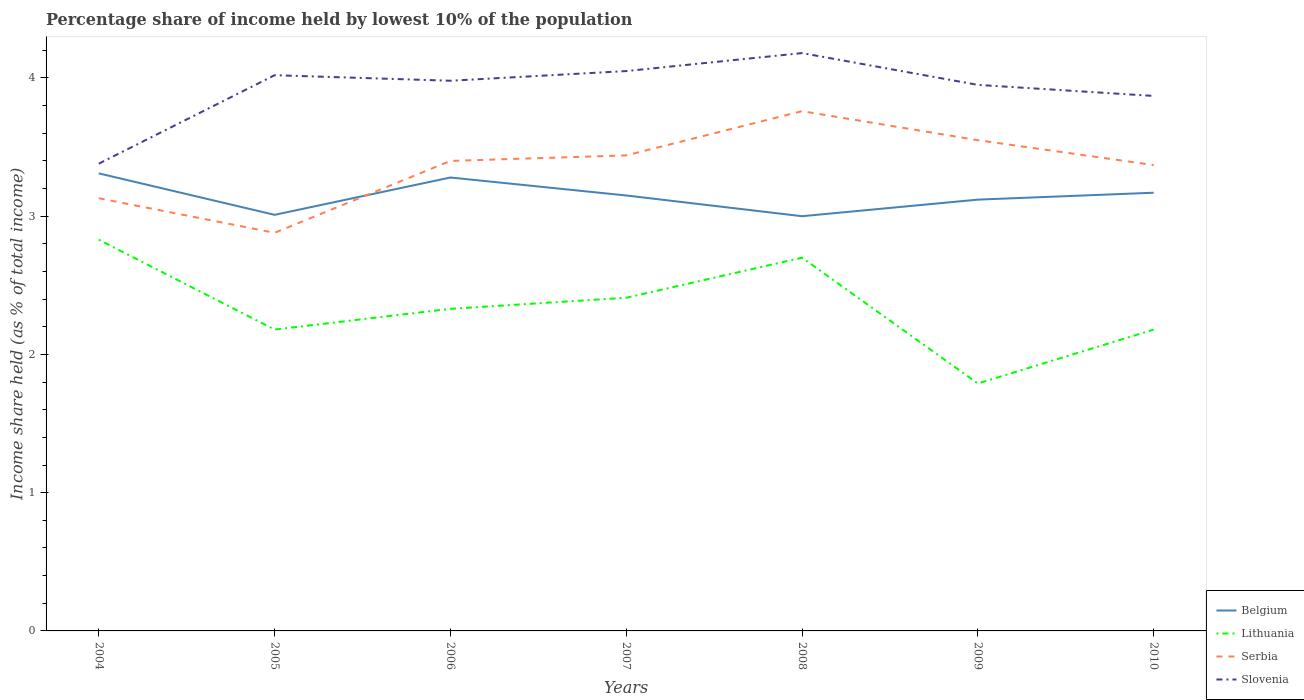Is the number of lines equal to the number of legend labels?
Provide a succinct answer. Yes. Across all years, what is the maximum percentage share of income held by lowest 10% of the population in Slovenia?
Keep it short and to the point. 3.38. What is the total percentage share of income held by lowest 10% of the population in Belgium in the graph?
Your response must be concise. -0.11. What is the difference between the highest and the second highest percentage share of income held by lowest 10% of the population in Slovenia?
Your answer should be compact. 0.8. How many lines are there?
Offer a terse response. 4. How many years are there in the graph?
Provide a short and direct response. 7. What is the difference between two consecutive major ticks on the Y-axis?
Offer a terse response. 1. Are the values on the major ticks of Y-axis written in scientific E-notation?
Make the answer very short. No. Does the graph contain any zero values?
Your response must be concise. No. Does the graph contain grids?
Make the answer very short. No. How many legend labels are there?
Offer a terse response. 4. How are the legend labels stacked?
Your response must be concise. Vertical. What is the title of the graph?
Keep it short and to the point. Percentage share of income held by lowest 10% of the population. Does "Slovenia" appear as one of the legend labels in the graph?
Provide a short and direct response. Yes. What is the label or title of the X-axis?
Offer a very short reply. Years. What is the label or title of the Y-axis?
Offer a very short reply. Income share held (as % of total income). What is the Income share held (as % of total income) in Belgium in 2004?
Make the answer very short. 3.31. What is the Income share held (as % of total income) of Lithuania in 2004?
Offer a very short reply. 2.83. What is the Income share held (as % of total income) in Serbia in 2004?
Provide a short and direct response. 3.13. What is the Income share held (as % of total income) in Slovenia in 2004?
Provide a short and direct response. 3.38. What is the Income share held (as % of total income) of Belgium in 2005?
Provide a succinct answer. 3.01. What is the Income share held (as % of total income) in Lithuania in 2005?
Offer a very short reply. 2.18. What is the Income share held (as % of total income) of Serbia in 2005?
Give a very brief answer. 2.88. What is the Income share held (as % of total income) in Slovenia in 2005?
Your response must be concise. 4.02. What is the Income share held (as % of total income) in Belgium in 2006?
Ensure brevity in your answer.  3.28. What is the Income share held (as % of total income) of Lithuania in 2006?
Your answer should be compact. 2.33. What is the Income share held (as % of total income) in Slovenia in 2006?
Provide a short and direct response. 3.98. What is the Income share held (as % of total income) in Belgium in 2007?
Provide a succinct answer. 3.15. What is the Income share held (as % of total income) of Lithuania in 2007?
Give a very brief answer. 2.41. What is the Income share held (as % of total income) of Serbia in 2007?
Offer a terse response. 3.44. What is the Income share held (as % of total income) of Slovenia in 2007?
Your response must be concise. 4.05. What is the Income share held (as % of total income) in Belgium in 2008?
Keep it short and to the point. 3. What is the Income share held (as % of total income) of Serbia in 2008?
Ensure brevity in your answer.  3.76. What is the Income share held (as % of total income) in Slovenia in 2008?
Provide a succinct answer. 4.18. What is the Income share held (as % of total income) in Belgium in 2009?
Ensure brevity in your answer.  3.12. What is the Income share held (as % of total income) of Lithuania in 2009?
Offer a terse response. 1.79. What is the Income share held (as % of total income) of Serbia in 2009?
Ensure brevity in your answer.  3.55. What is the Income share held (as % of total income) of Slovenia in 2009?
Your answer should be very brief. 3.95. What is the Income share held (as % of total income) in Belgium in 2010?
Your answer should be very brief. 3.17. What is the Income share held (as % of total income) of Lithuania in 2010?
Your answer should be compact. 2.18. What is the Income share held (as % of total income) of Serbia in 2010?
Your answer should be very brief. 3.37. What is the Income share held (as % of total income) in Slovenia in 2010?
Your answer should be compact. 3.87. Across all years, what is the maximum Income share held (as % of total income) in Belgium?
Keep it short and to the point. 3.31. Across all years, what is the maximum Income share held (as % of total income) of Lithuania?
Give a very brief answer. 2.83. Across all years, what is the maximum Income share held (as % of total income) in Serbia?
Your answer should be very brief. 3.76. Across all years, what is the maximum Income share held (as % of total income) of Slovenia?
Provide a short and direct response. 4.18. Across all years, what is the minimum Income share held (as % of total income) in Belgium?
Provide a short and direct response. 3. Across all years, what is the minimum Income share held (as % of total income) in Lithuania?
Provide a succinct answer. 1.79. Across all years, what is the minimum Income share held (as % of total income) in Serbia?
Give a very brief answer. 2.88. Across all years, what is the minimum Income share held (as % of total income) in Slovenia?
Your answer should be compact. 3.38. What is the total Income share held (as % of total income) in Belgium in the graph?
Your answer should be compact. 22.04. What is the total Income share held (as % of total income) of Lithuania in the graph?
Your answer should be very brief. 16.42. What is the total Income share held (as % of total income) of Serbia in the graph?
Provide a succinct answer. 23.53. What is the total Income share held (as % of total income) of Slovenia in the graph?
Your answer should be compact. 27.43. What is the difference between the Income share held (as % of total income) of Belgium in 2004 and that in 2005?
Your answer should be compact. 0.3. What is the difference between the Income share held (as % of total income) in Lithuania in 2004 and that in 2005?
Your response must be concise. 0.65. What is the difference between the Income share held (as % of total income) of Slovenia in 2004 and that in 2005?
Keep it short and to the point. -0.64. What is the difference between the Income share held (as % of total income) of Belgium in 2004 and that in 2006?
Your answer should be very brief. 0.03. What is the difference between the Income share held (as % of total income) of Serbia in 2004 and that in 2006?
Offer a very short reply. -0.27. What is the difference between the Income share held (as % of total income) of Belgium in 2004 and that in 2007?
Offer a very short reply. 0.16. What is the difference between the Income share held (as % of total income) of Lithuania in 2004 and that in 2007?
Your response must be concise. 0.42. What is the difference between the Income share held (as % of total income) in Serbia in 2004 and that in 2007?
Make the answer very short. -0.31. What is the difference between the Income share held (as % of total income) in Slovenia in 2004 and that in 2007?
Offer a very short reply. -0.67. What is the difference between the Income share held (as % of total income) of Belgium in 2004 and that in 2008?
Offer a terse response. 0.31. What is the difference between the Income share held (as % of total income) in Lithuania in 2004 and that in 2008?
Give a very brief answer. 0.13. What is the difference between the Income share held (as % of total income) of Serbia in 2004 and that in 2008?
Make the answer very short. -0.63. What is the difference between the Income share held (as % of total income) in Belgium in 2004 and that in 2009?
Give a very brief answer. 0.19. What is the difference between the Income share held (as % of total income) of Lithuania in 2004 and that in 2009?
Your answer should be compact. 1.04. What is the difference between the Income share held (as % of total income) in Serbia in 2004 and that in 2009?
Your answer should be very brief. -0.42. What is the difference between the Income share held (as % of total income) of Slovenia in 2004 and that in 2009?
Keep it short and to the point. -0.57. What is the difference between the Income share held (as % of total income) in Belgium in 2004 and that in 2010?
Your response must be concise. 0.14. What is the difference between the Income share held (as % of total income) of Lithuania in 2004 and that in 2010?
Keep it short and to the point. 0.65. What is the difference between the Income share held (as % of total income) in Serbia in 2004 and that in 2010?
Your answer should be very brief. -0.24. What is the difference between the Income share held (as % of total income) in Slovenia in 2004 and that in 2010?
Give a very brief answer. -0.49. What is the difference between the Income share held (as % of total income) of Belgium in 2005 and that in 2006?
Keep it short and to the point. -0.27. What is the difference between the Income share held (as % of total income) in Serbia in 2005 and that in 2006?
Offer a terse response. -0.52. What is the difference between the Income share held (as % of total income) of Slovenia in 2005 and that in 2006?
Provide a short and direct response. 0.04. What is the difference between the Income share held (as % of total income) in Belgium in 2005 and that in 2007?
Make the answer very short. -0.14. What is the difference between the Income share held (as % of total income) of Lithuania in 2005 and that in 2007?
Give a very brief answer. -0.23. What is the difference between the Income share held (as % of total income) in Serbia in 2005 and that in 2007?
Your answer should be very brief. -0.56. What is the difference between the Income share held (as % of total income) of Slovenia in 2005 and that in 2007?
Offer a terse response. -0.03. What is the difference between the Income share held (as % of total income) in Belgium in 2005 and that in 2008?
Offer a terse response. 0.01. What is the difference between the Income share held (as % of total income) of Lithuania in 2005 and that in 2008?
Ensure brevity in your answer.  -0.52. What is the difference between the Income share held (as % of total income) of Serbia in 2005 and that in 2008?
Provide a succinct answer. -0.88. What is the difference between the Income share held (as % of total income) of Slovenia in 2005 and that in 2008?
Offer a terse response. -0.16. What is the difference between the Income share held (as % of total income) in Belgium in 2005 and that in 2009?
Keep it short and to the point. -0.11. What is the difference between the Income share held (as % of total income) in Lithuania in 2005 and that in 2009?
Keep it short and to the point. 0.39. What is the difference between the Income share held (as % of total income) in Serbia in 2005 and that in 2009?
Give a very brief answer. -0.67. What is the difference between the Income share held (as % of total income) in Slovenia in 2005 and that in 2009?
Give a very brief answer. 0.07. What is the difference between the Income share held (as % of total income) of Belgium in 2005 and that in 2010?
Your response must be concise. -0.16. What is the difference between the Income share held (as % of total income) in Serbia in 2005 and that in 2010?
Provide a short and direct response. -0.49. What is the difference between the Income share held (as % of total income) in Slovenia in 2005 and that in 2010?
Your answer should be very brief. 0.15. What is the difference between the Income share held (as % of total income) of Belgium in 2006 and that in 2007?
Your response must be concise. 0.13. What is the difference between the Income share held (as % of total income) of Lithuania in 2006 and that in 2007?
Give a very brief answer. -0.08. What is the difference between the Income share held (as % of total income) in Serbia in 2006 and that in 2007?
Your answer should be very brief. -0.04. What is the difference between the Income share held (as % of total income) of Slovenia in 2006 and that in 2007?
Your answer should be compact. -0.07. What is the difference between the Income share held (as % of total income) in Belgium in 2006 and that in 2008?
Offer a very short reply. 0.28. What is the difference between the Income share held (as % of total income) in Lithuania in 2006 and that in 2008?
Your answer should be compact. -0.37. What is the difference between the Income share held (as % of total income) of Serbia in 2006 and that in 2008?
Offer a very short reply. -0.36. What is the difference between the Income share held (as % of total income) of Slovenia in 2006 and that in 2008?
Your answer should be very brief. -0.2. What is the difference between the Income share held (as % of total income) of Belgium in 2006 and that in 2009?
Provide a succinct answer. 0.16. What is the difference between the Income share held (as % of total income) of Lithuania in 2006 and that in 2009?
Offer a very short reply. 0.54. What is the difference between the Income share held (as % of total income) in Serbia in 2006 and that in 2009?
Offer a terse response. -0.15. What is the difference between the Income share held (as % of total income) of Belgium in 2006 and that in 2010?
Your response must be concise. 0.11. What is the difference between the Income share held (as % of total income) of Serbia in 2006 and that in 2010?
Provide a succinct answer. 0.03. What is the difference between the Income share held (as % of total income) of Slovenia in 2006 and that in 2010?
Offer a very short reply. 0.11. What is the difference between the Income share held (as % of total income) of Lithuania in 2007 and that in 2008?
Provide a short and direct response. -0.29. What is the difference between the Income share held (as % of total income) in Serbia in 2007 and that in 2008?
Your answer should be very brief. -0.32. What is the difference between the Income share held (as % of total income) in Slovenia in 2007 and that in 2008?
Offer a very short reply. -0.13. What is the difference between the Income share held (as % of total income) of Lithuania in 2007 and that in 2009?
Your response must be concise. 0.62. What is the difference between the Income share held (as % of total income) of Serbia in 2007 and that in 2009?
Offer a terse response. -0.11. What is the difference between the Income share held (as % of total income) of Slovenia in 2007 and that in 2009?
Make the answer very short. 0.1. What is the difference between the Income share held (as % of total income) in Belgium in 2007 and that in 2010?
Your answer should be compact. -0.02. What is the difference between the Income share held (as % of total income) of Lithuania in 2007 and that in 2010?
Ensure brevity in your answer.  0.23. What is the difference between the Income share held (as % of total income) in Serbia in 2007 and that in 2010?
Your response must be concise. 0.07. What is the difference between the Income share held (as % of total income) in Slovenia in 2007 and that in 2010?
Your answer should be very brief. 0.18. What is the difference between the Income share held (as % of total income) of Belgium in 2008 and that in 2009?
Provide a succinct answer. -0.12. What is the difference between the Income share held (as % of total income) in Lithuania in 2008 and that in 2009?
Your answer should be compact. 0.91. What is the difference between the Income share held (as % of total income) in Serbia in 2008 and that in 2009?
Your answer should be compact. 0.21. What is the difference between the Income share held (as % of total income) of Slovenia in 2008 and that in 2009?
Give a very brief answer. 0.23. What is the difference between the Income share held (as % of total income) in Belgium in 2008 and that in 2010?
Your answer should be compact. -0.17. What is the difference between the Income share held (as % of total income) of Lithuania in 2008 and that in 2010?
Provide a short and direct response. 0.52. What is the difference between the Income share held (as % of total income) in Serbia in 2008 and that in 2010?
Ensure brevity in your answer.  0.39. What is the difference between the Income share held (as % of total income) of Slovenia in 2008 and that in 2010?
Provide a short and direct response. 0.31. What is the difference between the Income share held (as % of total income) of Lithuania in 2009 and that in 2010?
Your answer should be very brief. -0.39. What is the difference between the Income share held (as % of total income) in Serbia in 2009 and that in 2010?
Make the answer very short. 0.18. What is the difference between the Income share held (as % of total income) in Slovenia in 2009 and that in 2010?
Offer a very short reply. 0.08. What is the difference between the Income share held (as % of total income) of Belgium in 2004 and the Income share held (as % of total income) of Lithuania in 2005?
Give a very brief answer. 1.13. What is the difference between the Income share held (as % of total income) of Belgium in 2004 and the Income share held (as % of total income) of Serbia in 2005?
Offer a very short reply. 0.43. What is the difference between the Income share held (as % of total income) of Belgium in 2004 and the Income share held (as % of total income) of Slovenia in 2005?
Your answer should be compact. -0.71. What is the difference between the Income share held (as % of total income) in Lithuania in 2004 and the Income share held (as % of total income) in Slovenia in 2005?
Offer a very short reply. -1.19. What is the difference between the Income share held (as % of total income) of Serbia in 2004 and the Income share held (as % of total income) of Slovenia in 2005?
Provide a succinct answer. -0.89. What is the difference between the Income share held (as % of total income) of Belgium in 2004 and the Income share held (as % of total income) of Lithuania in 2006?
Your response must be concise. 0.98. What is the difference between the Income share held (as % of total income) of Belgium in 2004 and the Income share held (as % of total income) of Serbia in 2006?
Keep it short and to the point. -0.09. What is the difference between the Income share held (as % of total income) in Belgium in 2004 and the Income share held (as % of total income) in Slovenia in 2006?
Your answer should be very brief. -0.67. What is the difference between the Income share held (as % of total income) of Lithuania in 2004 and the Income share held (as % of total income) of Serbia in 2006?
Offer a very short reply. -0.57. What is the difference between the Income share held (as % of total income) of Lithuania in 2004 and the Income share held (as % of total income) of Slovenia in 2006?
Your response must be concise. -1.15. What is the difference between the Income share held (as % of total income) of Serbia in 2004 and the Income share held (as % of total income) of Slovenia in 2006?
Give a very brief answer. -0.85. What is the difference between the Income share held (as % of total income) of Belgium in 2004 and the Income share held (as % of total income) of Serbia in 2007?
Give a very brief answer. -0.13. What is the difference between the Income share held (as % of total income) in Belgium in 2004 and the Income share held (as % of total income) in Slovenia in 2007?
Provide a short and direct response. -0.74. What is the difference between the Income share held (as % of total income) in Lithuania in 2004 and the Income share held (as % of total income) in Serbia in 2007?
Provide a succinct answer. -0.61. What is the difference between the Income share held (as % of total income) in Lithuania in 2004 and the Income share held (as % of total income) in Slovenia in 2007?
Offer a terse response. -1.22. What is the difference between the Income share held (as % of total income) in Serbia in 2004 and the Income share held (as % of total income) in Slovenia in 2007?
Provide a short and direct response. -0.92. What is the difference between the Income share held (as % of total income) of Belgium in 2004 and the Income share held (as % of total income) of Lithuania in 2008?
Keep it short and to the point. 0.61. What is the difference between the Income share held (as % of total income) in Belgium in 2004 and the Income share held (as % of total income) in Serbia in 2008?
Your answer should be compact. -0.45. What is the difference between the Income share held (as % of total income) of Belgium in 2004 and the Income share held (as % of total income) of Slovenia in 2008?
Ensure brevity in your answer.  -0.87. What is the difference between the Income share held (as % of total income) of Lithuania in 2004 and the Income share held (as % of total income) of Serbia in 2008?
Your response must be concise. -0.93. What is the difference between the Income share held (as % of total income) of Lithuania in 2004 and the Income share held (as % of total income) of Slovenia in 2008?
Ensure brevity in your answer.  -1.35. What is the difference between the Income share held (as % of total income) in Serbia in 2004 and the Income share held (as % of total income) in Slovenia in 2008?
Offer a very short reply. -1.05. What is the difference between the Income share held (as % of total income) of Belgium in 2004 and the Income share held (as % of total income) of Lithuania in 2009?
Your answer should be very brief. 1.52. What is the difference between the Income share held (as % of total income) of Belgium in 2004 and the Income share held (as % of total income) of Serbia in 2009?
Ensure brevity in your answer.  -0.24. What is the difference between the Income share held (as % of total income) of Belgium in 2004 and the Income share held (as % of total income) of Slovenia in 2009?
Ensure brevity in your answer.  -0.64. What is the difference between the Income share held (as % of total income) of Lithuania in 2004 and the Income share held (as % of total income) of Serbia in 2009?
Provide a succinct answer. -0.72. What is the difference between the Income share held (as % of total income) in Lithuania in 2004 and the Income share held (as % of total income) in Slovenia in 2009?
Your response must be concise. -1.12. What is the difference between the Income share held (as % of total income) of Serbia in 2004 and the Income share held (as % of total income) of Slovenia in 2009?
Your response must be concise. -0.82. What is the difference between the Income share held (as % of total income) in Belgium in 2004 and the Income share held (as % of total income) in Lithuania in 2010?
Ensure brevity in your answer.  1.13. What is the difference between the Income share held (as % of total income) of Belgium in 2004 and the Income share held (as % of total income) of Serbia in 2010?
Your response must be concise. -0.06. What is the difference between the Income share held (as % of total income) of Belgium in 2004 and the Income share held (as % of total income) of Slovenia in 2010?
Your response must be concise. -0.56. What is the difference between the Income share held (as % of total income) of Lithuania in 2004 and the Income share held (as % of total income) of Serbia in 2010?
Provide a short and direct response. -0.54. What is the difference between the Income share held (as % of total income) in Lithuania in 2004 and the Income share held (as % of total income) in Slovenia in 2010?
Ensure brevity in your answer.  -1.04. What is the difference between the Income share held (as % of total income) in Serbia in 2004 and the Income share held (as % of total income) in Slovenia in 2010?
Offer a terse response. -0.74. What is the difference between the Income share held (as % of total income) of Belgium in 2005 and the Income share held (as % of total income) of Lithuania in 2006?
Keep it short and to the point. 0.68. What is the difference between the Income share held (as % of total income) in Belgium in 2005 and the Income share held (as % of total income) in Serbia in 2006?
Provide a short and direct response. -0.39. What is the difference between the Income share held (as % of total income) of Belgium in 2005 and the Income share held (as % of total income) of Slovenia in 2006?
Your response must be concise. -0.97. What is the difference between the Income share held (as % of total income) in Lithuania in 2005 and the Income share held (as % of total income) in Serbia in 2006?
Keep it short and to the point. -1.22. What is the difference between the Income share held (as % of total income) in Lithuania in 2005 and the Income share held (as % of total income) in Slovenia in 2006?
Make the answer very short. -1.8. What is the difference between the Income share held (as % of total income) of Belgium in 2005 and the Income share held (as % of total income) of Lithuania in 2007?
Offer a very short reply. 0.6. What is the difference between the Income share held (as % of total income) of Belgium in 2005 and the Income share held (as % of total income) of Serbia in 2007?
Your answer should be compact. -0.43. What is the difference between the Income share held (as % of total income) in Belgium in 2005 and the Income share held (as % of total income) in Slovenia in 2007?
Your response must be concise. -1.04. What is the difference between the Income share held (as % of total income) of Lithuania in 2005 and the Income share held (as % of total income) of Serbia in 2007?
Offer a very short reply. -1.26. What is the difference between the Income share held (as % of total income) of Lithuania in 2005 and the Income share held (as % of total income) of Slovenia in 2007?
Offer a terse response. -1.87. What is the difference between the Income share held (as % of total income) in Serbia in 2005 and the Income share held (as % of total income) in Slovenia in 2007?
Give a very brief answer. -1.17. What is the difference between the Income share held (as % of total income) in Belgium in 2005 and the Income share held (as % of total income) in Lithuania in 2008?
Provide a succinct answer. 0.31. What is the difference between the Income share held (as % of total income) of Belgium in 2005 and the Income share held (as % of total income) of Serbia in 2008?
Keep it short and to the point. -0.75. What is the difference between the Income share held (as % of total income) in Belgium in 2005 and the Income share held (as % of total income) in Slovenia in 2008?
Your answer should be compact. -1.17. What is the difference between the Income share held (as % of total income) of Lithuania in 2005 and the Income share held (as % of total income) of Serbia in 2008?
Your response must be concise. -1.58. What is the difference between the Income share held (as % of total income) in Belgium in 2005 and the Income share held (as % of total income) in Lithuania in 2009?
Your answer should be compact. 1.22. What is the difference between the Income share held (as % of total income) of Belgium in 2005 and the Income share held (as % of total income) of Serbia in 2009?
Your answer should be very brief. -0.54. What is the difference between the Income share held (as % of total income) in Belgium in 2005 and the Income share held (as % of total income) in Slovenia in 2009?
Give a very brief answer. -0.94. What is the difference between the Income share held (as % of total income) in Lithuania in 2005 and the Income share held (as % of total income) in Serbia in 2009?
Your answer should be very brief. -1.37. What is the difference between the Income share held (as % of total income) in Lithuania in 2005 and the Income share held (as % of total income) in Slovenia in 2009?
Provide a succinct answer. -1.77. What is the difference between the Income share held (as % of total income) in Serbia in 2005 and the Income share held (as % of total income) in Slovenia in 2009?
Give a very brief answer. -1.07. What is the difference between the Income share held (as % of total income) of Belgium in 2005 and the Income share held (as % of total income) of Lithuania in 2010?
Offer a terse response. 0.83. What is the difference between the Income share held (as % of total income) in Belgium in 2005 and the Income share held (as % of total income) in Serbia in 2010?
Make the answer very short. -0.36. What is the difference between the Income share held (as % of total income) of Belgium in 2005 and the Income share held (as % of total income) of Slovenia in 2010?
Offer a terse response. -0.86. What is the difference between the Income share held (as % of total income) of Lithuania in 2005 and the Income share held (as % of total income) of Serbia in 2010?
Your response must be concise. -1.19. What is the difference between the Income share held (as % of total income) of Lithuania in 2005 and the Income share held (as % of total income) of Slovenia in 2010?
Provide a succinct answer. -1.69. What is the difference between the Income share held (as % of total income) of Serbia in 2005 and the Income share held (as % of total income) of Slovenia in 2010?
Your answer should be very brief. -0.99. What is the difference between the Income share held (as % of total income) of Belgium in 2006 and the Income share held (as % of total income) of Lithuania in 2007?
Make the answer very short. 0.87. What is the difference between the Income share held (as % of total income) of Belgium in 2006 and the Income share held (as % of total income) of Serbia in 2007?
Provide a short and direct response. -0.16. What is the difference between the Income share held (as % of total income) of Belgium in 2006 and the Income share held (as % of total income) of Slovenia in 2007?
Keep it short and to the point. -0.77. What is the difference between the Income share held (as % of total income) of Lithuania in 2006 and the Income share held (as % of total income) of Serbia in 2007?
Ensure brevity in your answer.  -1.11. What is the difference between the Income share held (as % of total income) in Lithuania in 2006 and the Income share held (as % of total income) in Slovenia in 2007?
Provide a short and direct response. -1.72. What is the difference between the Income share held (as % of total income) in Serbia in 2006 and the Income share held (as % of total income) in Slovenia in 2007?
Offer a terse response. -0.65. What is the difference between the Income share held (as % of total income) in Belgium in 2006 and the Income share held (as % of total income) in Lithuania in 2008?
Provide a short and direct response. 0.58. What is the difference between the Income share held (as % of total income) of Belgium in 2006 and the Income share held (as % of total income) of Serbia in 2008?
Offer a very short reply. -0.48. What is the difference between the Income share held (as % of total income) in Belgium in 2006 and the Income share held (as % of total income) in Slovenia in 2008?
Make the answer very short. -0.9. What is the difference between the Income share held (as % of total income) of Lithuania in 2006 and the Income share held (as % of total income) of Serbia in 2008?
Provide a succinct answer. -1.43. What is the difference between the Income share held (as % of total income) in Lithuania in 2006 and the Income share held (as % of total income) in Slovenia in 2008?
Provide a short and direct response. -1.85. What is the difference between the Income share held (as % of total income) of Serbia in 2006 and the Income share held (as % of total income) of Slovenia in 2008?
Keep it short and to the point. -0.78. What is the difference between the Income share held (as % of total income) in Belgium in 2006 and the Income share held (as % of total income) in Lithuania in 2009?
Offer a very short reply. 1.49. What is the difference between the Income share held (as % of total income) in Belgium in 2006 and the Income share held (as % of total income) in Serbia in 2009?
Give a very brief answer. -0.27. What is the difference between the Income share held (as % of total income) in Belgium in 2006 and the Income share held (as % of total income) in Slovenia in 2009?
Give a very brief answer. -0.67. What is the difference between the Income share held (as % of total income) in Lithuania in 2006 and the Income share held (as % of total income) in Serbia in 2009?
Your answer should be compact. -1.22. What is the difference between the Income share held (as % of total income) in Lithuania in 2006 and the Income share held (as % of total income) in Slovenia in 2009?
Provide a succinct answer. -1.62. What is the difference between the Income share held (as % of total income) of Serbia in 2006 and the Income share held (as % of total income) of Slovenia in 2009?
Make the answer very short. -0.55. What is the difference between the Income share held (as % of total income) of Belgium in 2006 and the Income share held (as % of total income) of Serbia in 2010?
Offer a very short reply. -0.09. What is the difference between the Income share held (as % of total income) in Belgium in 2006 and the Income share held (as % of total income) in Slovenia in 2010?
Offer a terse response. -0.59. What is the difference between the Income share held (as % of total income) of Lithuania in 2006 and the Income share held (as % of total income) of Serbia in 2010?
Your answer should be very brief. -1.04. What is the difference between the Income share held (as % of total income) in Lithuania in 2006 and the Income share held (as % of total income) in Slovenia in 2010?
Provide a succinct answer. -1.54. What is the difference between the Income share held (as % of total income) of Serbia in 2006 and the Income share held (as % of total income) of Slovenia in 2010?
Your answer should be compact. -0.47. What is the difference between the Income share held (as % of total income) of Belgium in 2007 and the Income share held (as % of total income) of Lithuania in 2008?
Make the answer very short. 0.45. What is the difference between the Income share held (as % of total income) of Belgium in 2007 and the Income share held (as % of total income) of Serbia in 2008?
Give a very brief answer. -0.61. What is the difference between the Income share held (as % of total income) in Belgium in 2007 and the Income share held (as % of total income) in Slovenia in 2008?
Make the answer very short. -1.03. What is the difference between the Income share held (as % of total income) in Lithuania in 2007 and the Income share held (as % of total income) in Serbia in 2008?
Your response must be concise. -1.35. What is the difference between the Income share held (as % of total income) of Lithuania in 2007 and the Income share held (as % of total income) of Slovenia in 2008?
Ensure brevity in your answer.  -1.77. What is the difference between the Income share held (as % of total income) of Serbia in 2007 and the Income share held (as % of total income) of Slovenia in 2008?
Ensure brevity in your answer.  -0.74. What is the difference between the Income share held (as % of total income) of Belgium in 2007 and the Income share held (as % of total income) of Lithuania in 2009?
Make the answer very short. 1.36. What is the difference between the Income share held (as % of total income) of Belgium in 2007 and the Income share held (as % of total income) of Serbia in 2009?
Give a very brief answer. -0.4. What is the difference between the Income share held (as % of total income) in Lithuania in 2007 and the Income share held (as % of total income) in Serbia in 2009?
Offer a very short reply. -1.14. What is the difference between the Income share held (as % of total income) in Lithuania in 2007 and the Income share held (as % of total income) in Slovenia in 2009?
Offer a terse response. -1.54. What is the difference between the Income share held (as % of total income) of Serbia in 2007 and the Income share held (as % of total income) of Slovenia in 2009?
Ensure brevity in your answer.  -0.51. What is the difference between the Income share held (as % of total income) of Belgium in 2007 and the Income share held (as % of total income) of Lithuania in 2010?
Ensure brevity in your answer.  0.97. What is the difference between the Income share held (as % of total income) in Belgium in 2007 and the Income share held (as % of total income) in Serbia in 2010?
Keep it short and to the point. -0.22. What is the difference between the Income share held (as % of total income) of Belgium in 2007 and the Income share held (as % of total income) of Slovenia in 2010?
Provide a succinct answer. -0.72. What is the difference between the Income share held (as % of total income) in Lithuania in 2007 and the Income share held (as % of total income) in Serbia in 2010?
Give a very brief answer. -0.96. What is the difference between the Income share held (as % of total income) of Lithuania in 2007 and the Income share held (as % of total income) of Slovenia in 2010?
Provide a succinct answer. -1.46. What is the difference between the Income share held (as % of total income) of Serbia in 2007 and the Income share held (as % of total income) of Slovenia in 2010?
Your answer should be very brief. -0.43. What is the difference between the Income share held (as % of total income) in Belgium in 2008 and the Income share held (as % of total income) in Lithuania in 2009?
Offer a terse response. 1.21. What is the difference between the Income share held (as % of total income) in Belgium in 2008 and the Income share held (as % of total income) in Serbia in 2009?
Ensure brevity in your answer.  -0.55. What is the difference between the Income share held (as % of total income) in Belgium in 2008 and the Income share held (as % of total income) in Slovenia in 2009?
Provide a succinct answer. -0.95. What is the difference between the Income share held (as % of total income) of Lithuania in 2008 and the Income share held (as % of total income) of Serbia in 2009?
Provide a short and direct response. -0.85. What is the difference between the Income share held (as % of total income) in Lithuania in 2008 and the Income share held (as % of total income) in Slovenia in 2009?
Make the answer very short. -1.25. What is the difference between the Income share held (as % of total income) of Serbia in 2008 and the Income share held (as % of total income) of Slovenia in 2009?
Your answer should be very brief. -0.19. What is the difference between the Income share held (as % of total income) in Belgium in 2008 and the Income share held (as % of total income) in Lithuania in 2010?
Keep it short and to the point. 0.82. What is the difference between the Income share held (as % of total income) in Belgium in 2008 and the Income share held (as % of total income) in Serbia in 2010?
Make the answer very short. -0.37. What is the difference between the Income share held (as % of total income) in Belgium in 2008 and the Income share held (as % of total income) in Slovenia in 2010?
Your response must be concise. -0.87. What is the difference between the Income share held (as % of total income) in Lithuania in 2008 and the Income share held (as % of total income) in Serbia in 2010?
Offer a terse response. -0.67. What is the difference between the Income share held (as % of total income) in Lithuania in 2008 and the Income share held (as % of total income) in Slovenia in 2010?
Provide a succinct answer. -1.17. What is the difference between the Income share held (as % of total income) in Serbia in 2008 and the Income share held (as % of total income) in Slovenia in 2010?
Provide a succinct answer. -0.11. What is the difference between the Income share held (as % of total income) in Belgium in 2009 and the Income share held (as % of total income) in Serbia in 2010?
Provide a succinct answer. -0.25. What is the difference between the Income share held (as % of total income) of Belgium in 2009 and the Income share held (as % of total income) of Slovenia in 2010?
Provide a succinct answer. -0.75. What is the difference between the Income share held (as % of total income) in Lithuania in 2009 and the Income share held (as % of total income) in Serbia in 2010?
Your answer should be compact. -1.58. What is the difference between the Income share held (as % of total income) of Lithuania in 2009 and the Income share held (as % of total income) of Slovenia in 2010?
Make the answer very short. -2.08. What is the difference between the Income share held (as % of total income) of Serbia in 2009 and the Income share held (as % of total income) of Slovenia in 2010?
Make the answer very short. -0.32. What is the average Income share held (as % of total income) in Belgium per year?
Your answer should be compact. 3.15. What is the average Income share held (as % of total income) of Lithuania per year?
Keep it short and to the point. 2.35. What is the average Income share held (as % of total income) of Serbia per year?
Provide a succinct answer. 3.36. What is the average Income share held (as % of total income) in Slovenia per year?
Give a very brief answer. 3.92. In the year 2004, what is the difference between the Income share held (as % of total income) of Belgium and Income share held (as % of total income) of Lithuania?
Offer a terse response. 0.48. In the year 2004, what is the difference between the Income share held (as % of total income) of Belgium and Income share held (as % of total income) of Serbia?
Keep it short and to the point. 0.18. In the year 2004, what is the difference between the Income share held (as % of total income) in Belgium and Income share held (as % of total income) in Slovenia?
Offer a very short reply. -0.07. In the year 2004, what is the difference between the Income share held (as % of total income) in Lithuania and Income share held (as % of total income) in Serbia?
Offer a terse response. -0.3. In the year 2004, what is the difference between the Income share held (as % of total income) of Lithuania and Income share held (as % of total income) of Slovenia?
Your response must be concise. -0.55. In the year 2005, what is the difference between the Income share held (as % of total income) of Belgium and Income share held (as % of total income) of Lithuania?
Give a very brief answer. 0.83. In the year 2005, what is the difference between the Income share held (as % of total income) of Belgium and Income share held (as % of total income) of Serbia?
Your answer should be compact. 0.13. In the year 2005, what is the difference between the Income share held (as % of total income) in Belgium and Income share held (as % of total income) in Slovenia?
Give a very brief answer. -1.01. In the year 2005, what is the difference between the Income share held (as % of total income) in Lithuania and Income share held (as % of total income) in Serbia?
Provide a succinct answer. -0.7. In the year 2005, what is the difference between the Income share held (as % of total income) of Lithuania and Income share held (as % of total income) of Slovenia?
Your response must be concise. -1.84. In the year 2005, what is the difference between the Income share held (as % of total income) in Serbia and Income share held (as % of total income) in Slovenia?
Your answer should be compact. -1.14. In the year 2006, what is the difference between the Income share held (as % of total income) in Belgium and Income share held (as % of total income) in Lithuania?
Your answer should be compact. 0.95. In the year 2006, what is the difference between the Income share held (as % of total income) of Belgium and Income share held (as % of total income) of Serbia?
Your answer should be compact. -0.12. In the year 2006, what is the difference between the Income share held (as % of total income) of Lithuania and Income share held (as % of total income) of Serbia?
Keep it short and to the point. -1.07. In the year 2006, what is the difference between the Income share held (as % of total income) in Lithuania and Income share held (as % of total income) in Slovenia?
Your answer should be very brief. -1.65. In the year 2006, what is the difference between the Income share held (as % of total income) of Serbia and Income share held (as % of total income) of Slovenia?
Make the answer very short. -0.58. In the year 2007, what is the difference between the Income share held (as % of total income) of Belgium and Income share held (as % of total income) of Lithuania?
Make the answer very short. 0.74. In the year 2007, what is the difference between the Income share held (as % of total income) of Belgium and Income share held (as % of total income) of Serbia?
Make the answer very short. -0.29. In the year 2007, what is the difference between the Income share held (as % of total income) in Lithuania and Income share held (as % of total income) in Serbia?
Offer a terse response. -1.03. In the year 2007, what is the difference between the Income share held (as % of total income) of Lithuania and Income share held (as % of total income) of Slovenia?
Give a very brief answer. -1.64. In the year 2007, what is the difference between the Income share held (as % of total income) of Serbia and Income share held (as % of total income) of Slovenia?
Make the answer very short. -0.61. In the year 2008, what is the difference between the Income share held (as % of total income) in Belgium and Income share held (as % of total income) in Serbia?
Your answer should be very brief. -0.76. In the year 2008, what is the difference between the Income share held (as % of total income) of Belgium and Income share held (as % of total income) of Slovenia?
Give a very brief answer. -1.18. In the year 2008, what is the difference between the Income share held (as % of total income) in Lithuania and Income share held (as % of total income) in Serbia?
Keep it short and to the point. -1.06. In the year 2008, what is the difference between the Income share held (as % of total income) in Lithuania and Income share held (as % of total income) in Slovenia?
Your answer should be very brief. -1.48. In the year 2008, what is the difference between the Income share held (as % of total income) of Serbia and Income share held (as % of total income) of Slovenia?
Provide a succinct answer. -0.42. In the year 2009, what is the difference between the Income share held (as % of total income) of Belgium and Income share held (as % of total income) of Lithuania?
Your answer should be compact. 1.33. In the year 2009, what is the difference between the Income share held (as % of total income) of Belgium and Income share held (as % of total income) of Serbia?
Offer a very short reply. -0.43. In the year 2009, what is the difference between the Income share held (as % of total income) of Belgium and Income share held (as % of total income) of Slovenia?
Offer a very short reply. -0.83. In the year 2009, what is the difference between the Income share held (as % of total income) in Lithuania and Income share held (as % of total income) in Serbia?
Keep it short and to the point. -1.76. In the year 2009, what is the difference between the Income share held (as % of total income) in Lithuania and Income share held (as % of total income) in Slovenia?
Your answer should be compact. -2.16. In the year 2010, what is the difference between the Income share held (as % of total income) in Belgium and Income share held (as % of total income) in Lithuania?
Offer a terse response. 0.99. In the year 2010, what is the difference between the Income share held (as % of total income) of Belgium and Income share held (as % of total income) of Serbia?
Your response must be concise. -0.2. In the year 2010, what is the difference between the Income share held (as % of total income) of Lithuania and Income share held (as % of total income) of Serbia?
Your answer should be very brief. -1.19. In the year 2010, what is the difference between the Income share held (as % of total income) of Lithuania and Income share held (as % of total income) of Slovenia?
Provide a succinct answer. -1.69. In the year 2010, what is the difference between the Income share held (as % of total income) of Serbia and Income share held (as % of total income) of Slovenia?
Give a very brief answer. -0.5. What is the ratio of the Income share held (as % of total income) in Belgium in 2004 to that in 2005?
Keep it short and to the point. 1.1. What is the ratio of the Income share held (as % of total income) in Lithuania in 2004 to that in 2005?
Offer a very short reply. 1.3. What is the ratio of the Income share held (as % of total income) of Serbia in 2004 to that in 2005?
Make the answer very short. 1.09. What is the ratio of the Income share held (as % of total income) in Slovenia in 2004 to that in 2005?
Offer a very short reply. 0.84. What is the ratio of the Income share held (as % of total income) of Belgium in 2004 to that in 2006?
Your answer should be very brief. 1.01. What is the ratio of the Income share held (as % of total income) in Lithuania in 2004 to that in 2006?
Your response must be concise. 1.21. What is the ratio of the Income share held (as % of total income) in Serbia in 2004 to that in 2006?
Offer a very short reply. 0.92. What is the ratio of the Income share held (as % of total income) in Slovenia in 2004 to that in 2006?
Your response must be concise. 0.85. What is the ratio of the Income share held (as % of total income) of Belgium in 2004 to that in 2007?
Provide a succinct answer. 1.05. What is the ratio of the Income share held (as % of total income) in Lithuania in 2004 to that in 2007?
Make the answer very short. 1.17. What is the ratio of the Income share held (as % of total income) of Serbia in 2004 to that in 2007?
Keep it short and to the point. 0.91. What is the ratio of the Income share held (as % of total income) in Slovenia in 2004 to that in 2007?
Your response must be concise. 0.83. What is the ratio of the Income share held (as % of total income) of Belgium in 2004 to that in 2008?
Keep it short and to the point. 1.1. What is the ratio of the Income share held (as % of total income) of Lithuania in 2004 to that in 2008?
Your response must be concise. 1.05. What is the ratio of the Income share held (as % of total income) of Serbia in 2004 to that in 2008?
Keep it short and to the point. 0.83. What is the ratio of the Income share held (as % of total income) of Slovenia in 2004 to that in 2008?
Keep it short and to the point. 0.81. What is the ratio of the Income share held (as % of total income) in Belgium in 2004 to that in 2009?
Provide a short and direct response. 1.06. What is the ratio of the Income share held (as % of total income) in Lithuania in 2004 to that in 2009?
Offer a terse response. 1.58. What is the ratio of the Income share held (as % of total income) of Serbia in 2004 to that in 2009?
Keep it short and to the point. 0.88. What is the ratio of the Income share held (as % of total income) of Slovenia in 2004 to that in 2009?
Provide a short and direct response. 0.86. What is the ratio of the Income share held (as % of total income) in Belgium in 2004 to that in 2010?
Your answer should be very brief. 1.04. What is the ratio of the Income share held (as % of total income) in Lithuania in 2004 to that in 2010?
Ensure brevity in your answer.  1.3. What is the ratio of the Income share held (as % of total income) of Serbia in 2004 to that in 2010?
Give a very brief answer. 0.93. What is the ratio of the Income share held (as % of total income) of Slovenia in 2004 to that in 2010?
Provide a short and direct response. 0.87. What is the ratio of the Income share held (as % of total income) in Belgium in 2005 to that in 2006?
Provide a succinct answer. 0.92. What is the ratio of the Income share held (as % of total income) of Lithuania in 2005 to that in 2006?
Provide a short and direct response. 0.94. What is the ratio of the Income share held (as % of total income) in Serbia in 2005 to that in 2006?
Provide a succinct answer. 0.85. What is the ratio of the Income share held (as % of total income) in Belgium in 2005 to that in 2007?
Offer a very short reply. 0.96. What is the ratio of the Income share held (as % of total income) in Lithuania in 2005 to that in 2007?
Your answer should be very brief. 0.9. What is the ratio of the Income share held (as % of total income) of Serbia in 2005 to that in 2007?
Keep it short and to the point. 0.84. What is the ratio of the Income share held (as % of total income) in Belgium in 2005 to that in 2008?
Your answer should be very brief. 1. What is the ratio of the Income share held (as % of total income) in Lithuania in 2005 to that in 2008?
Your answer should be very brief. 0.81. What is the ratio of the Income share held (as % of total income) of Serbia in 2005 to that in 2008?
Offer a very short reply. 0.77. What is the ratio of the Income share held (as % of total income) in Slovenia in 2005 to that in 2008?
Provide a short and direct response. 0.96. What is the ratio of the Income share held (as % of total income) of Belgium in 2005 to that in 2009?
Offer a very short reply. 0.96. What is the ratio of the Income share held (as % of total income) of Lithuania in 2005 to that in 2009?
Make the answer very short. 1.22. What is the ratio of the Income share held (as % of total income) in Serbia in 2005 to that in 2009?
Your response must be concise. 0.81. What is the ratio of the Income share held (as % of total income) of Slovenia in 2005 to that in 2009?
Offer a very short reply. 1.02. What is the ratio of the Income share held (as % of total income) in Belgium in 2005 to that in 2010?
Keep it short and to the point. 0.95. What is the ratio of the Income share held (as % of total income) in Serbia in 2005 to that in 2010?
Give a very brief answer. 0.85. What is the ratio of the Income share held (as % of total income) of Slovenia in 2005 to that in 2010?
Make the answer very short. 1.04. What is the ratio of the Income share held (as % of total income) in Belgium in 2006 to that in 2007?
Provide a succinct answer. 1.04. What is the ratio of the Income share held (as % of total income) in Lithuania in 2006 to that in 2007?
Provide a succinct answer. 0.97. What is the ratio of the Income share held (as % of total income) of Serbia in 2006 to that in 2007?
Provide a succinct answer. 0.99. What is the ratio of the Income share held (as % of total income) in Slovenia in 2006 to that in 2007?
Keep it short and to the point. 0.98. What is the ratio of the Income share held (as % of total income) in Belgium in 2006 to that in 2008?
Ensure brevity in your answer.  1.09. What is the ratio of the Income share held (as % of total income) of Lithuania in 2006 to that in 2008?
Offer a terse response. 0.86. What is the ratio of the Income share held (as % of total income) of Serbia in 2006 to that in 2008?
Keep it short and to the point. 0.9. What is the ratio of the Income share held (as % of total income) in Slovenia in 2006 to that in 2008?
Ensure brevity in your answer.  0.95. What is the ratio of the Income share held (as % of total income) in Belgium in 2006 to that in 2009?
Offer a very short reply. 1.05. What is the ratio of the Income share held (as % of total income) of Lithuania in 2006 to that in 2009?
Keep it short and to the point. 1.3. What is the ratio of the Income share held (as % of total income) of Serbia in 2006 to that in 2009?
Your response must be concise. 0.96. What is the ratio of the Income share held (as % of total income) of Slovenia in 2006 to that in 2009?
Your response must be concise. 1.01. What is the ratio of the Income share held (as % of total income) of Belgium in 2006 to that in 2010?
Provide a succinct answer. 1.03. What is the ratio of the Income share held (as % of total income) of Lithuania in 2006 to that in 2010?
Your answer should be compact. 1.07. What is the ratio of the Income share held (as % of total income) in Serbia in 2006 to that in 2010?
Offer a terse response. 1.01. What is the ratio of the Income share held (as % of total income) of Slovenia in 2006 to that in 2010?
Make the answer very short. 1.03. What is the ratio of the Income share held (as % of total income) of Belgium in 2007 to that in 2008?
Your answer should be very brief. 1.05. What is the ratio of the Income share held (as % of total income) of Lithuania in 2007 to that in 2008?
Offer a terse response. 0.89. What is the ratio of the Income share held (as % of total income) of Serbia in 2007 to that in 2008?
Offer a terse response. 0.91. What is the ratio of the Income share held (as % of total income) of Slovenia in 2007 to that in 2008?
Provide a short and direct response. 0.97. What is the ratio of the Income share held (as % of total income) of Belgium in 2007 to that in 2009?
Keep it short and to the point. 1.01. What is the ratio of the Income share held (as % of total income) of Lithuania in 2007 to that in 2009?
Provide a succinct answer. 1.35. What is the ratio of the Income share held (as % of total income) in Serbia in 2007 to that in 2009?
Provide a short and direct response. 0.97. What is the ratio of the Income share held (as % of total income) in Slovenia in 2007 to that in 2009?
Provide a succinct answer. 1.03. What is the ratio of the Income share held (as % of total income) of Belgium in 2007 to that in 2010?
Your response must be concise. 0.99. What is the ratio of the Income share held (as % of total income) in Lithuania in 2007 to that in 2010?
Provide a short and direct response. 1.11. What is the ratio of the Income share held (as % of total income) in Serbia in 2007 to that in 2010?
Make the answer very short. 1.02. What is the ratio of the Income share held (as % of total income) of Slovenia in 2007 to that in 2010?
Offer a very short reply. 1.05. What is the ratio of the Income share held (as % of total income) of Belgium in 2008 to that in 2009?
Your answer should be very brief. 0.96. What is the ratio of the Income share held (as % of total income) in Lithuania in 2008 to that in 2009?
Your answer should be compact. 1.51. What is the ratio of the Income share held (as % of total income) of Serbia in 2008 to that in 2009?
Your answer should be very brief. 1.06. What is the ratio of the Income share held (as % of total income) of Slovenia in 2008 to that in 2009?
Your response must be concise. 1.06. What is the ratio of the Income share held (as % of total income) of Belgium in 2008 to that in 2010?
Your response must be concise. 0.95. What is the ratio of the Income share held (as % of total income) in Lithuania in 2008 to that in 2010?
Offer a terse response. 1.24. What is the ratio of the Income share held (as % of total income) in Serbia in 2008 to that in 2010?
Provide a short and direct response. 1.12. What is the ratio of the Income share held (as % of total income) of Slovenia in 2008 to that in 2010?
Give a very brief answer. 1.08. What is the ratio of the Income share held (as % of total income) in Belgium in 2009 to that in 2010?
Offer a terse response. 0.98. What is the ratio of the Income share held (as % of total income) of Lithuania in 2009 to that in 2010?
Your response must be concise. 0.82. What is the ratio of the Income share held (as % of total income) in Serbia in 2009 to that in 2010?
Provide a short and direct response. 1.05. What is the ratio of the Income share held (as % of total income) of Slovenia in 2009 to that in 2010?
Your answer should be very brief. 1.02. What is the difference between the highest and the second highest Income share held (as % of total income) in Belgium?
Make the answer very short. 0.03. What is the difference between the highest and the second highest Income share held (as % of total income) of Lithuania?
Make the answer very short. 0.13. What is the difference between the highest and the second highest Income share held (as % of total income) of Serbia?
Make the answer very short. 0.21. What is the difference between the highest and the second highest Income share held (as % of total income) in Slovenia?
Keep it short and to the point. 0.13. What is the difference between the highest and the lowest Income share held (as % of total income) in Belgium?
Give a very brief answer. 0.31. What is the difference between the highest and the lowest Income share held (as % of total income) in Lithuania?
Offer a terse response. 1.04. 